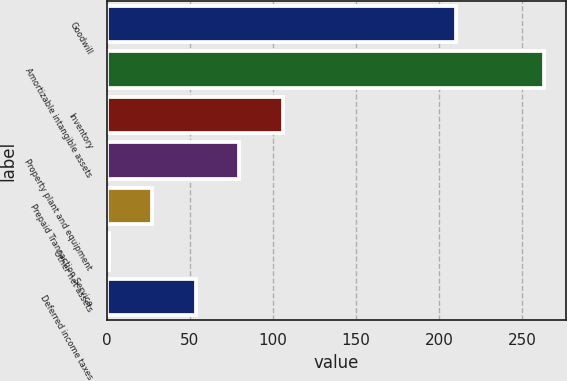Convert chart. <chart><loc_0><loc_0><loc_500><loc_500><bar_chart><fcel>Goodwill<fcel>Amortizable intangible assets<fcel>Inventory<fcel>Property plant and equipment<fcel>Prepaid Transaction Service<fcel>Other net assets<fcel>Deferred income taxes<nl><fcel>210<fcel>263<fcel>105.8<fcel>79.6<fcel>27.2<fcel>1<fcel>53.4<nl></chart> 